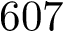Convert formula to latex. <formula><loc_0><loc_0><loc_500><loc_500>6 0 7</formula> 